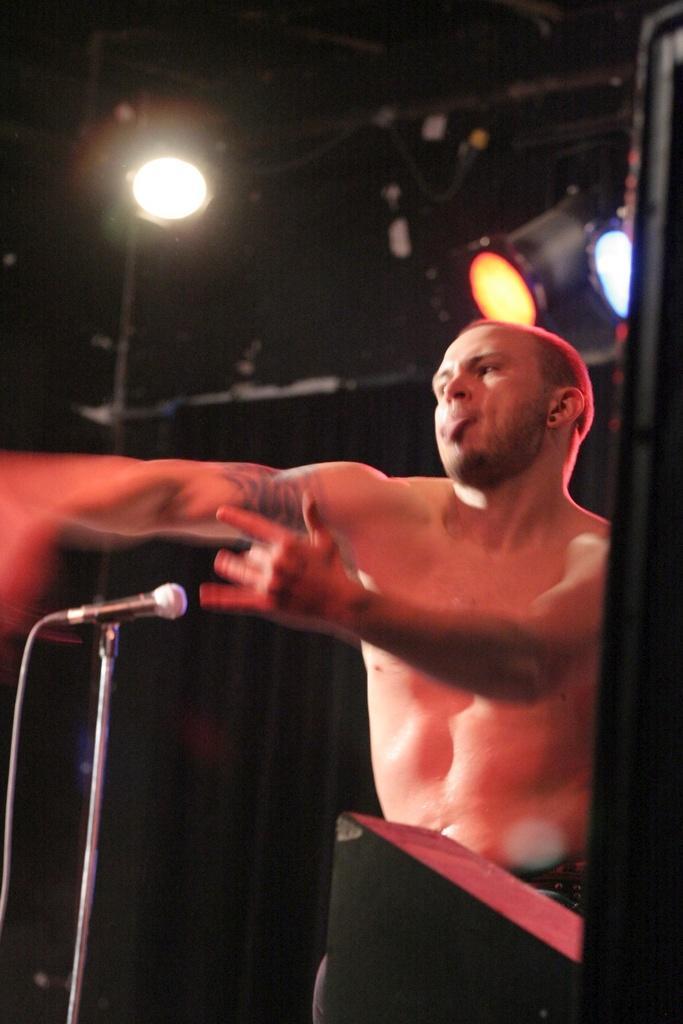How would you summarize this image in a sentence or two? In this image we can see a man, before him there is a mic placed on the stand. In the background there are lights. 